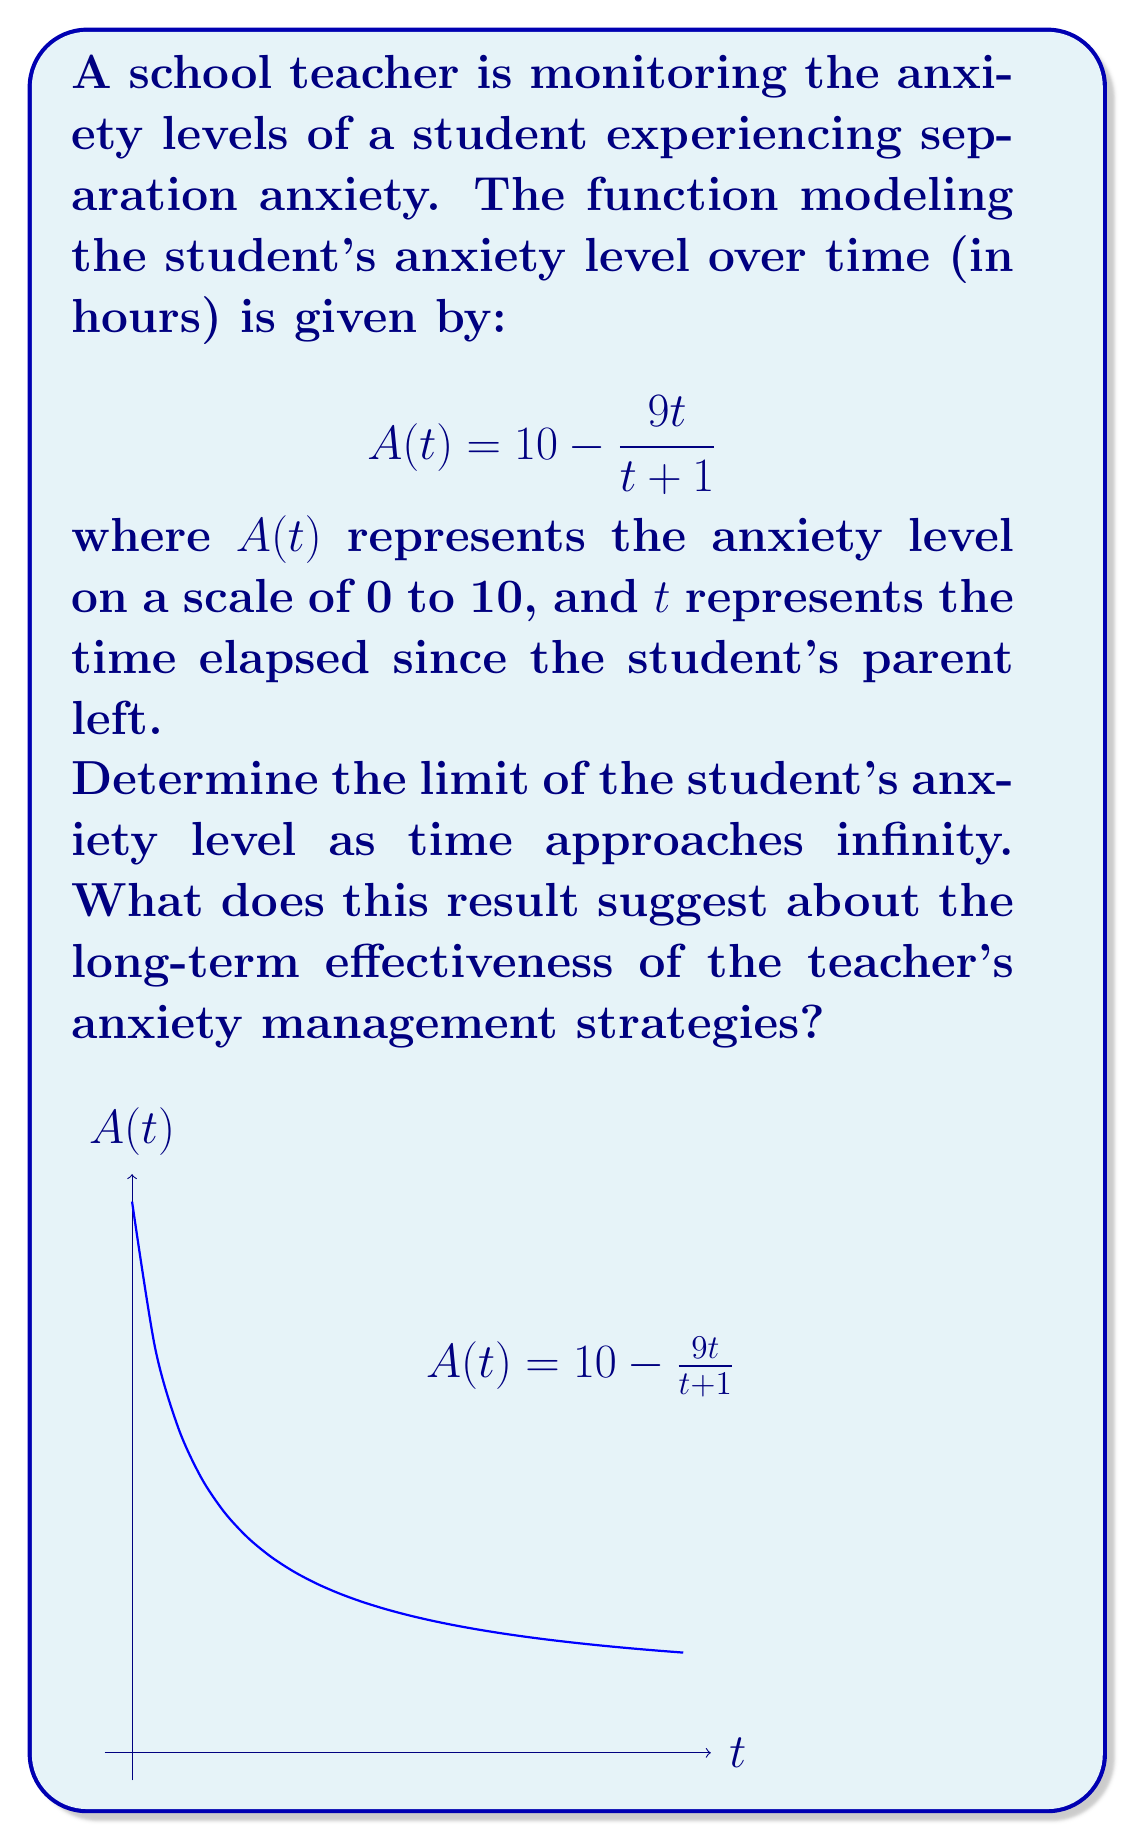Can you answer this question? To determine the limit of the anxiety function as time approaches infinity, we follow these steps:

1) We need to evaluate $\lim_{t \to \infty} A(t)$.

2) Substituting the given function:

   $$\lim_{t \to \infty} A(t) = \lim_{t \to \infty} \left(10 - \frac{9t}{t+1}\right)$$

3) We can separate this into two limits:

   $$\lim_{t \to \infty} 10 - \lim_{t \to \infty} \frac{9t}{t+1}$$

4) The first limit is straightforward: $\lim_{t \to \infty} 10 = 10$

5) For the second limit, both numerator and denominator approach infinity. We can use the following technique:

   $$\lim_{t \to \infty} \frac{9t}{t+1} = \lim_{t \to \infty} \frac{9t/t}{(t+1)/t} = \lim_{t \to \infty} \frac{9}{1+1/t} = 9$$

6) Therefore, the overall limit is:

   $$\lim_{t \to \infty} A(t) = 10 - 9 = 1$$

This result suggests that over time, the student's anxiety level approaches 1 on the 0-10 scale. This indicates that the teacher's anxiety management strategies are effective in the long term, as the student's anxiety significantly decreases from the initial higher levels.
Answer: $\lim_{t \to \infty} A(t) = 1$ 